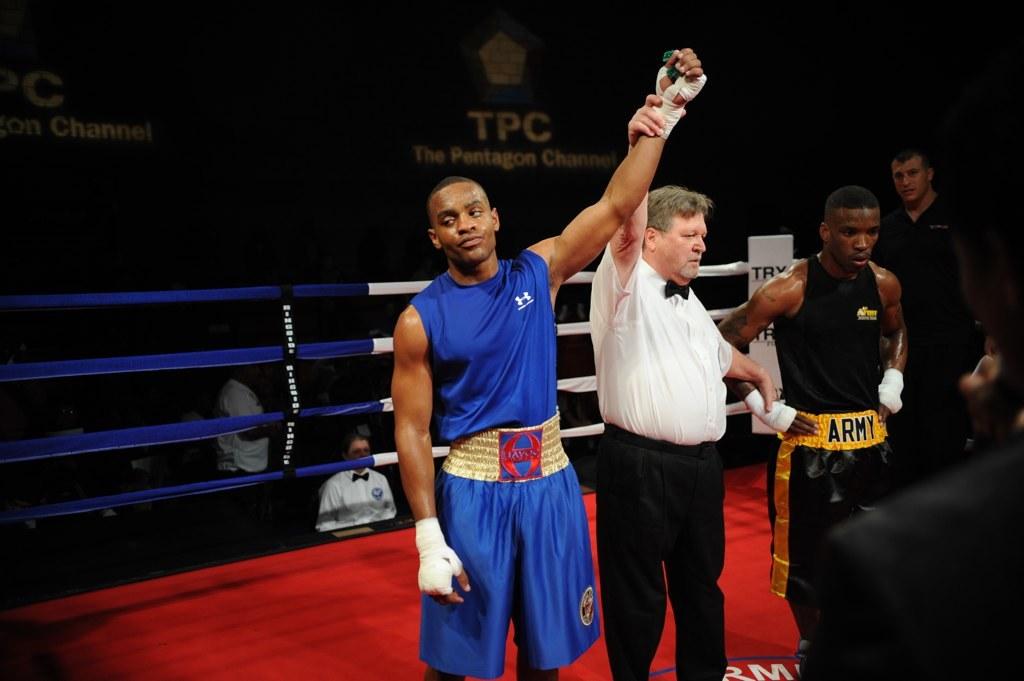What is written on the black shirt player's belt?
Provide a succinct answer. Army. What television channel aired this fight?
Give a very brief answer. Unanswerable. 